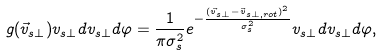Convert formula to latex. <formula><loc_0><loc_0><loc_500><loc_500>g ( \vec { v } _ { s \perp } ) v _ { s \perp } d v _ { s \perp } d \varphi = \frac { 1 } { \pi \sigma _ { s } ^ { 2 } } e ^ { - \frac { ( \vec { v } _ { s \perp } - \vec { v } _ { s \perp , r o t } ) ^ { 2 } } { \sigma _ { s } ^ { 2 } } } v _ { s \perp } d v _ { s \perp } d \varphi ,</formula> 